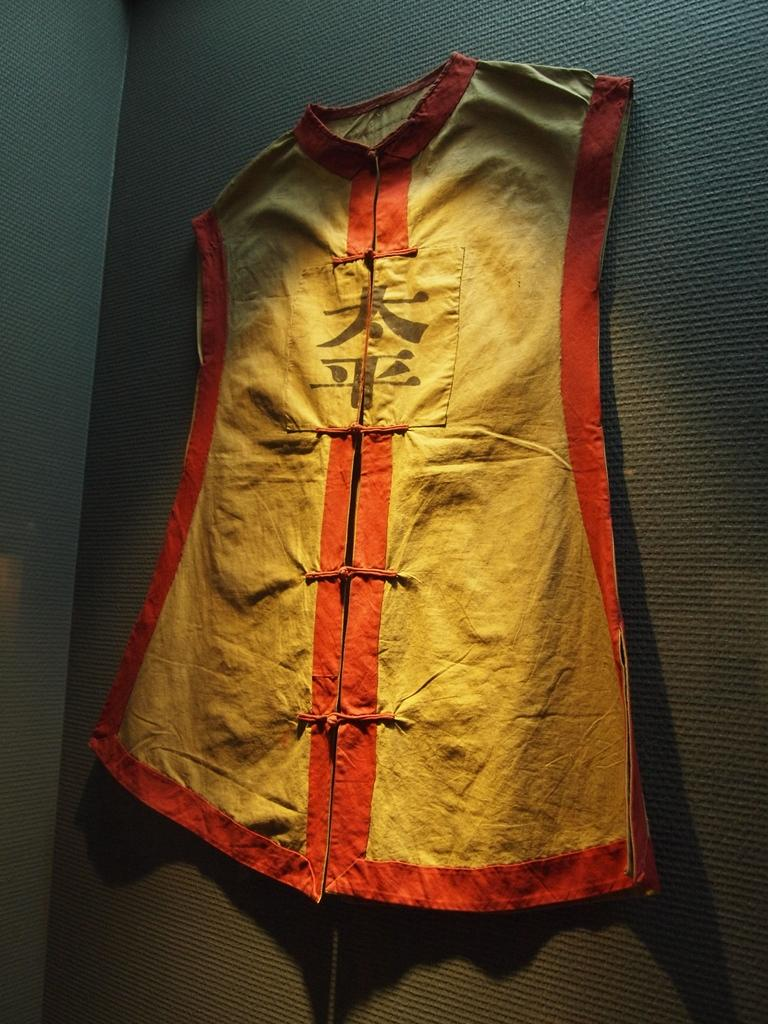What is hanging on the wall in the image? There is a jacket in the image that is attached to the wall. How is the jacket positioned on the wall? The jacket is attached to the wall. What type of voice can be heard coming from the jacket in the image? There is no voice coming from the jacket in the image, as it is an inanimate object. 